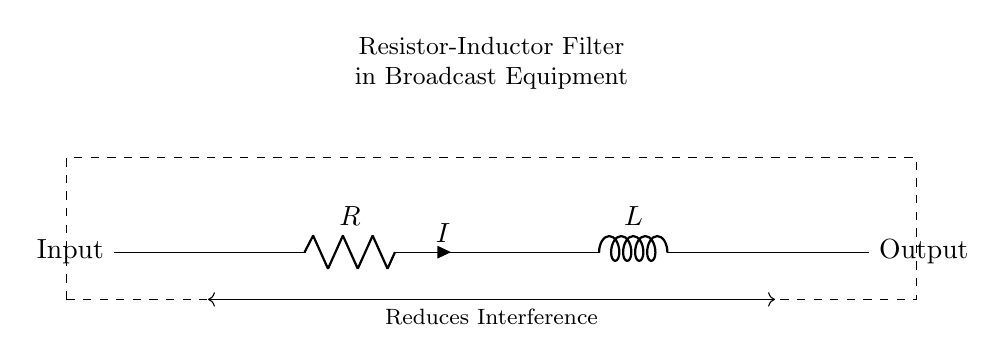What are the components in this circuit? The components are a resistor and an inductor. They are both shown in the diagram, indicating their roles in the filter circuit.
Answer: Resistor, Inductor What is the purpose of this circuit? The purpose of this circuit is to reduce interference in broadcast equipment, as indicated by the labeled connection showing reduction of interference.
Answer: Reduce interference What is the current flowing through this circuit? The current is labeled as I between the resistor and inductor, indicating that this is the current flowing through the circuit during operation.
Answer: I What type of filter is this circuit? This circuit is a low-pass filter, as it allows low-frequency signals to pass while reducing high-frequency noise, typical of resistor-inductor configurations.
Answer: Low-pass filter How are the components connected in the circuit? The resistor and inductor are connected in series, with the input connected to the resistor and the output taken from the inductor, creating a direct path for current.
Answer: In series What is the input in this circuit? The input is the signal that enters the circuit at the leftmost side, where the dashed box begins, indicating it receives an incoming signal to filter.
Answer: Signal input What effect does the inductor have on the circuit? The inductor opposes changes in current and filters out high-frequency signals, working with the resistor to create the desired low-pass filtering effect.
Answer: Filters high-frequency signals 